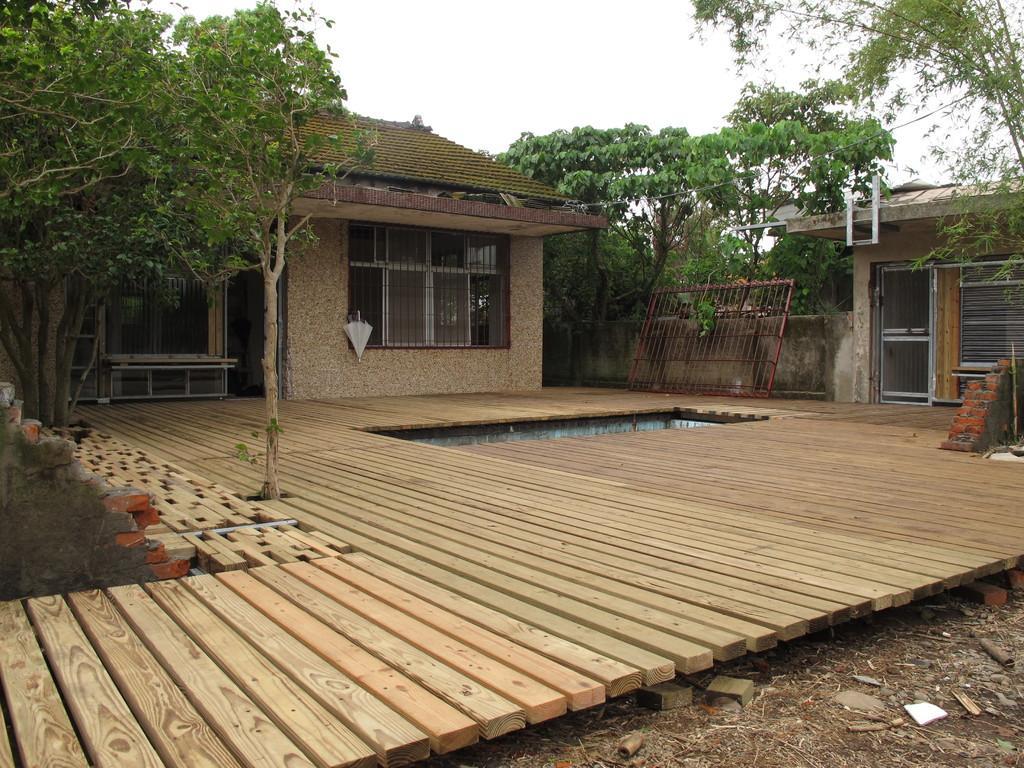Could you give a brief overview of what you see in this image? In this image I see the houses and I see the wooden platform and I see number of trees. In the background I see the sky and I see the ground over here and I see the walls 